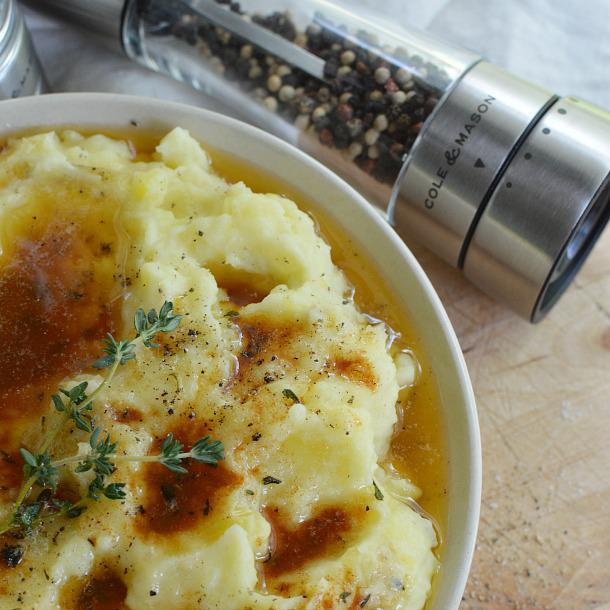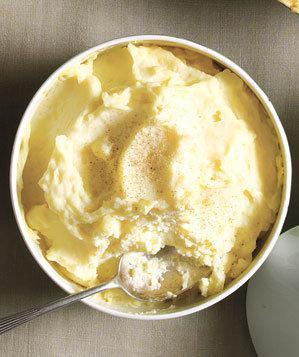The first image is the image on the left, the second image is the image on the right. Evaluate the accuracy of this statement regarding the images: "A cylindrical spice grinder is laying alongside a bowl of mashed potatoes doused with brownish liquid.". Is it true? Answer yes or no. Yes. The first image is the image on the left, the second image is the image on the right. Considering the images on both sides, is "There is a cylindrical, silver pepper grinder behind a bowl of mashed potatoes in one of the images." valid? Answer yes or no. Yes. 